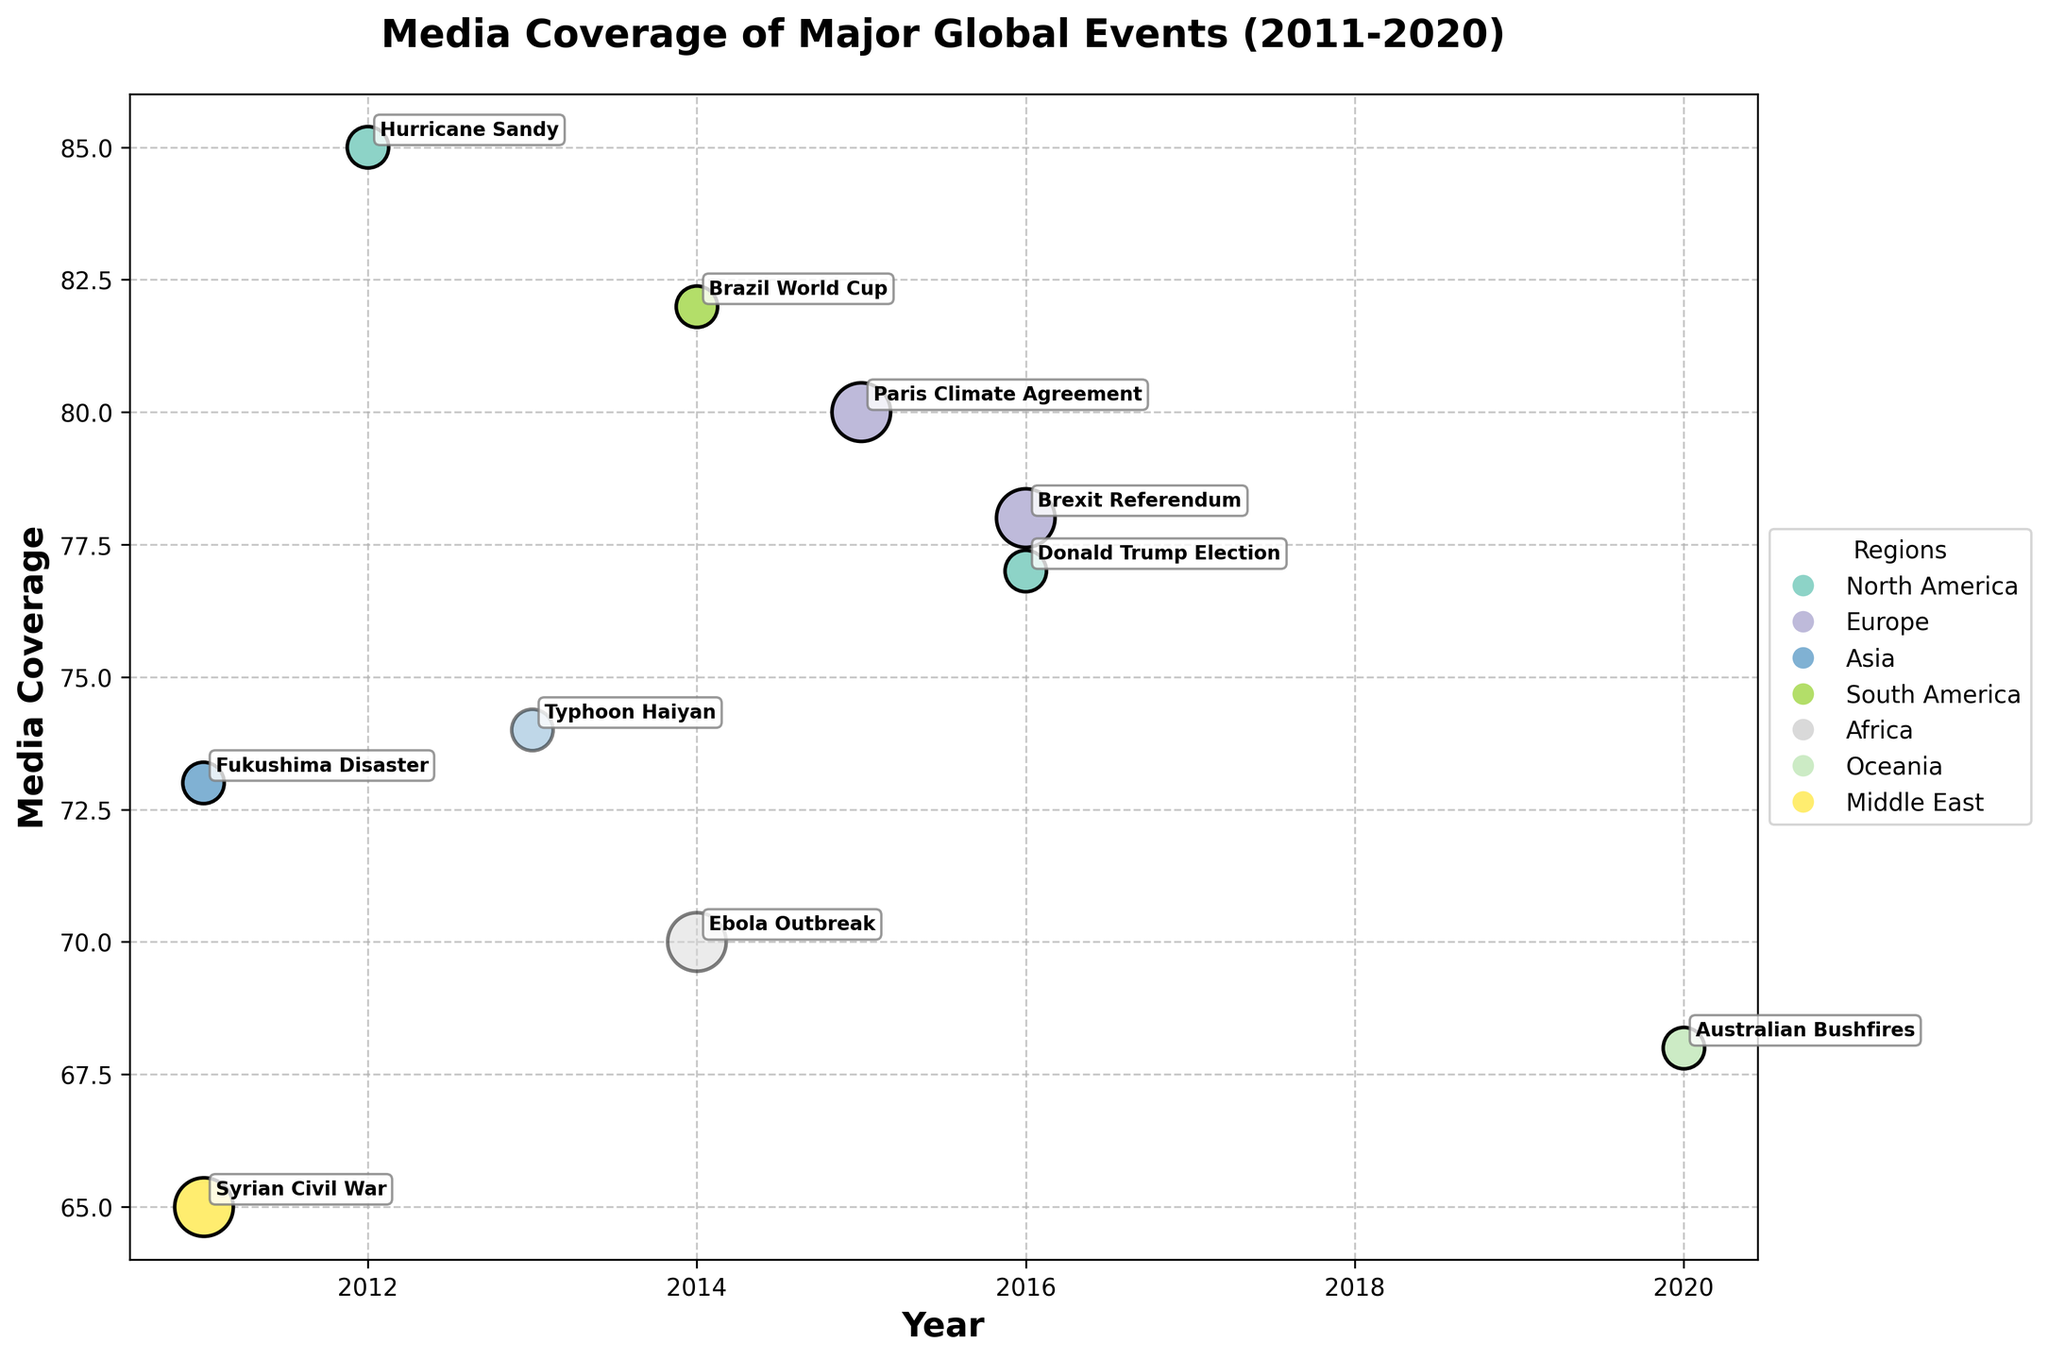What is the title of the figure? The title of the figure is typically found at the top of the plot area in a larger or bold font compared to the rest of the text. Here, it is "Media Coverage of Major Global Events (2011-2020)".
Answer: Media Coverage of Major Global Events (2011-2020) Which event in the Middle East received the highest media coverage? Locate the color associated with the Middle East in the legend, then find the data point in the Middle East region with the highest y-axis value labeled "Media Coverage". Here, "Syrian Civil War" has the highest coverage in the Middle East at 65.
Answer: Syrian Civil War What year had the highest overall media coverage? Identify the data point with the highest y-axis value and read the corresponding x-axis value for the year. "Hurricane Sandy" in 2012 with a media coverage of 85 is the highest.
Answer: 2012 Which events are represented by the largest bubbles? Identify the bubbles with the largest size (indicative of "EventImpact" being "very_high") and note the events associated with those bubbles. These include "Brexit Referendum", "Paris Climate Agreement", and "Ebola Outbreak".
Answer: Brexit Referendum, Paris Climate Agreement, Ebola Outbreak Which region has the most events represented on the plot? Count the number of events (bubbles) for each region by looking at the legend colors and matching them with the bubbles in the plot. Europe has the most events with three: "Brexit Referendum", "Paris Climate Agreement", and "Fukushima Disaster".
Answer: Europe How does media coverage of the 2016 European event compare to the 2016 North American event? Locate the events for 2016 in Europe and North America and compare their y-axis values. The "Brexit Referendum" in Europe (78) is slightly higher than "Donald Trump Election" in North America (77).
Answer: Brexit Referendum is higher What is the average media coverage for events in North America? Identify all North American events, look at their media coverage values, sum them up and divide by the number of events. The events are "Hurricane Sandy" (85) and "Donald Trump Election" (77). (85 + 77) / 2 = 81.
Answer: 81 Which two events occurred in 2011, and what were their media coverage levels? Identify the data points for 2011 on the x-axis and note the events and their corresponding y-axis values. The events are "Syrian Civil War" with 65 and "Fukushima Disaster" with 73.
Answer: Syrian Civil War (65), Fukushima Disaster (73) What impact category correlates with the smallest bubble sizes, and which events fall into this category? Identify the smallest bubble sizes and look for their color and alpha attributes, which represent "EventImpact" labeled as "high". The event in this category is "Typhoon Haiyan".
Answer: Typhoon Haiyan 